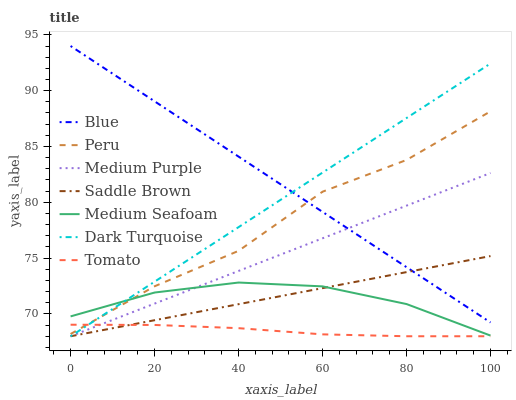Does Dark Turquoise have the minimum area under the curve?
Answer yes or no. No. Does Dark Turquoise have the maximum area under the curve?
Answer yes or no. No. Is Tomato the smoothest?
Answer yes or no. No. Is Tomato the roughest?
Answer yes or no. No. Does Medium Seafoam have the lowest value?
Answer yes or no. No. Does Dark Turquoise have the highest value?
Answer yes or no. No. Is Medium Purple less than Peru?
Answer yes or no. Yes. Is Peru greater than Saddle Brown?
Answer yes or no. Yes. Does Medium Purple intersect Peru?
Answer yes or no. No. 